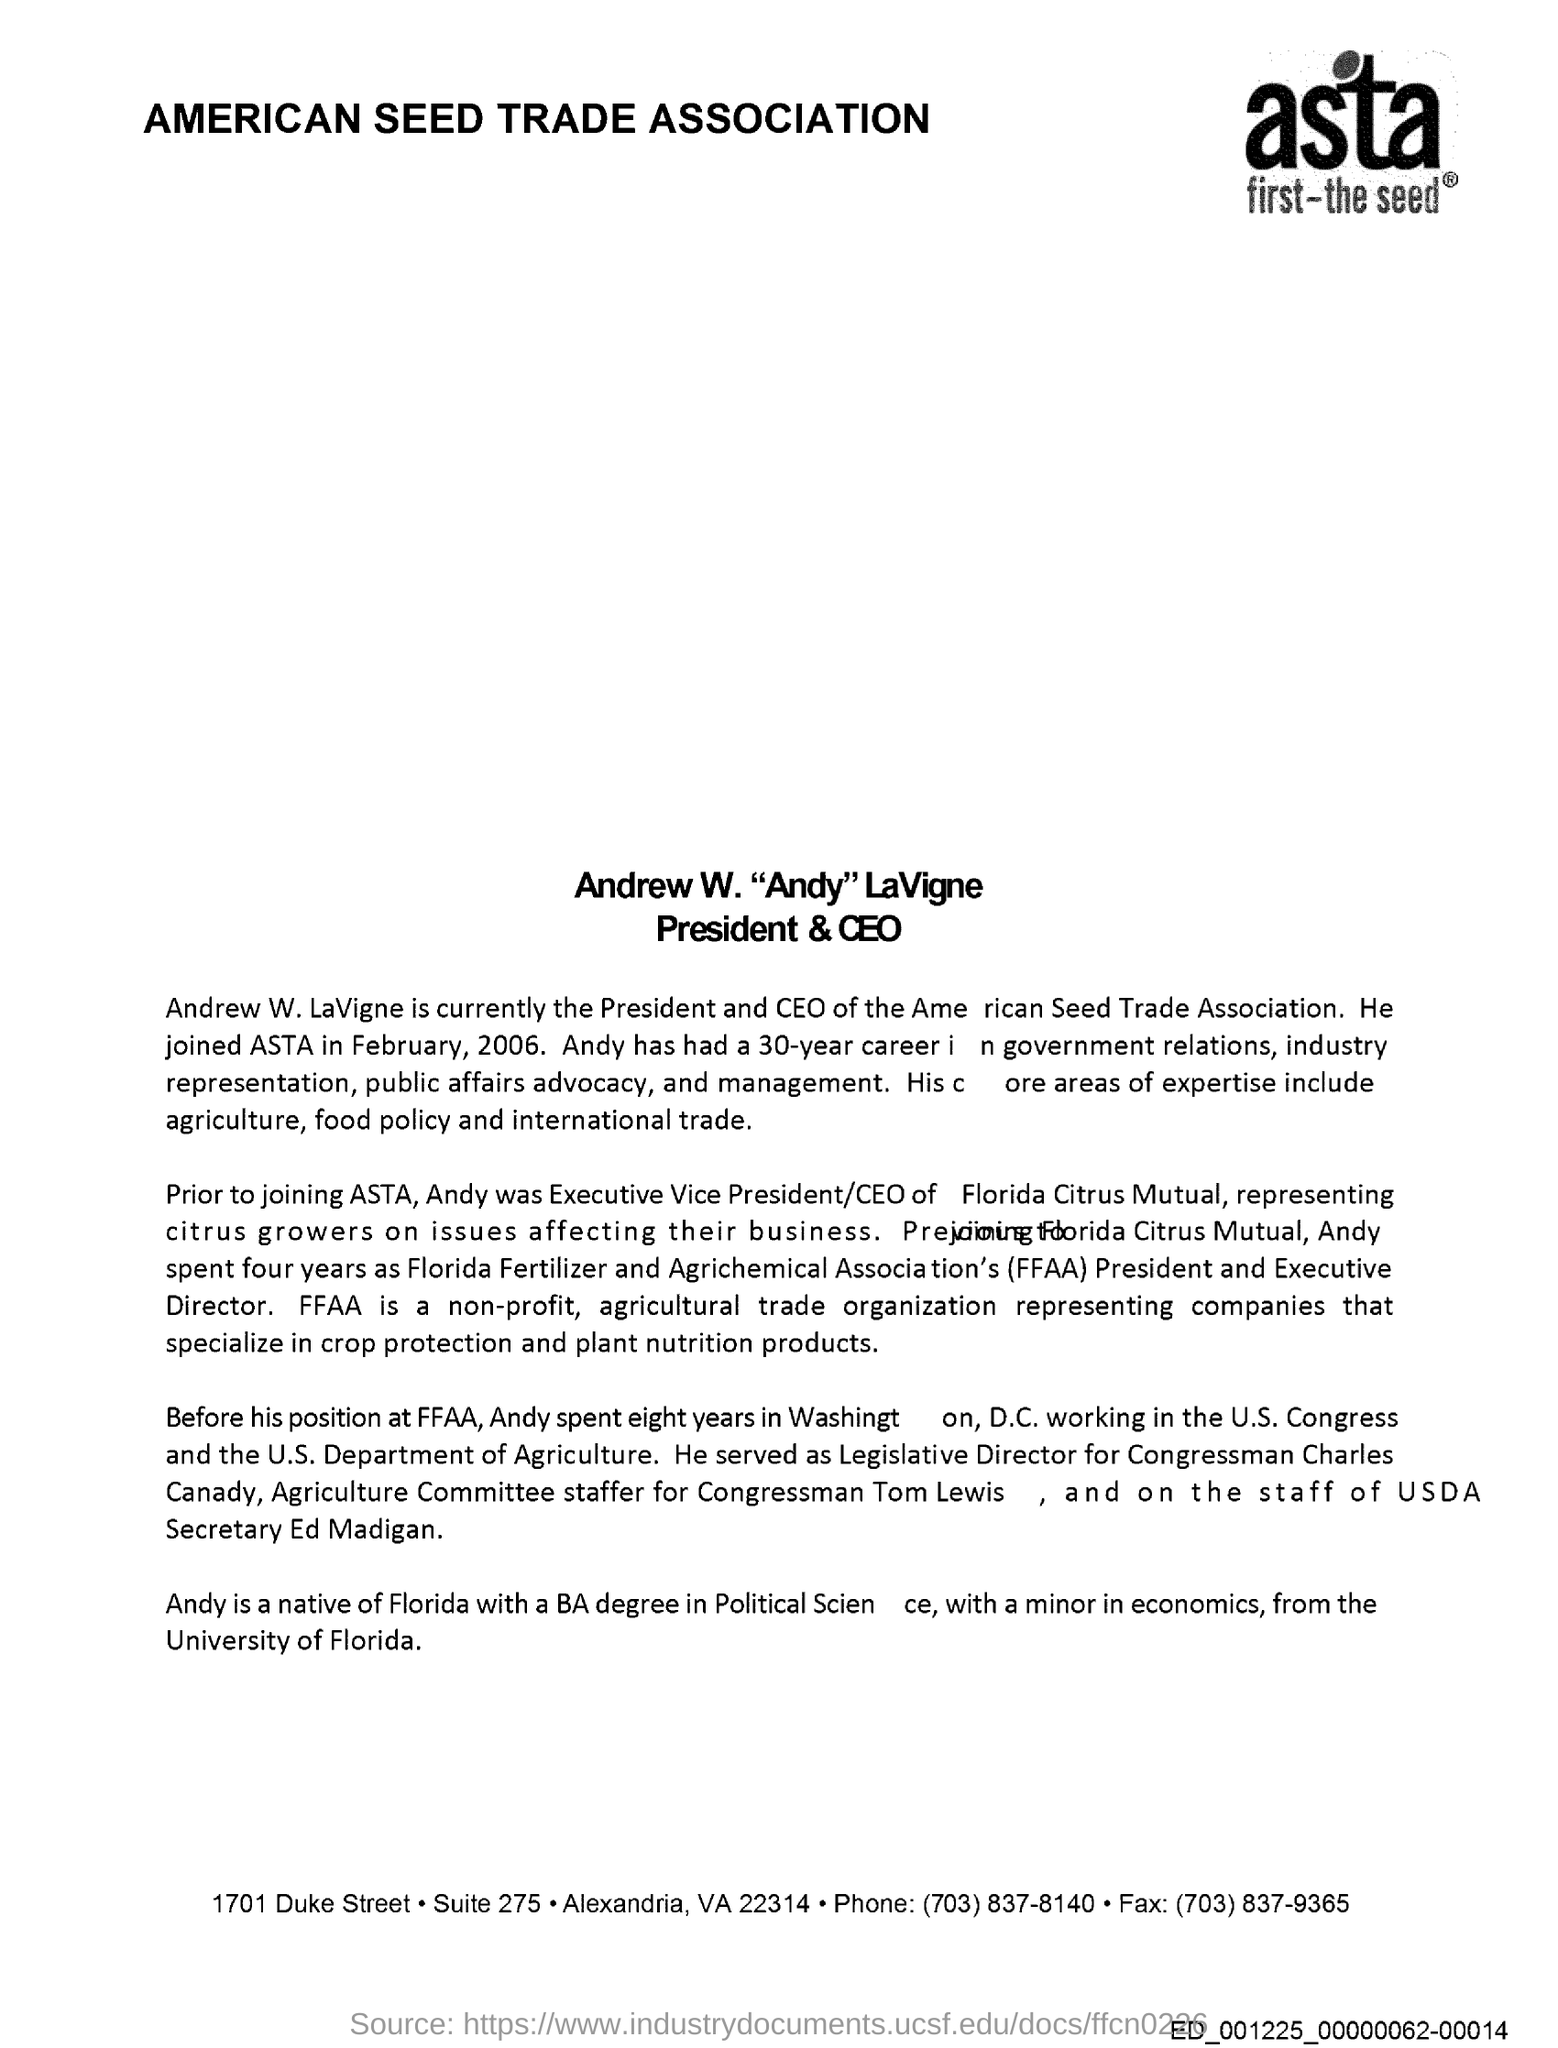Who is currently the President and CEO of the American Seed Trade Association?
Keep it short and to the point. Andrew W.LaVigne. When Andrew W.LaVigne joined ASTA
Provide a short and direct response. February, 2006. What core areas of expertise include ?
Ensure brevity in your answer.  Agriculture, food policy and international trade. What does FFAA stands for ?
Make the answer very short. Florida Fertilizer and Agrichemical Association. 